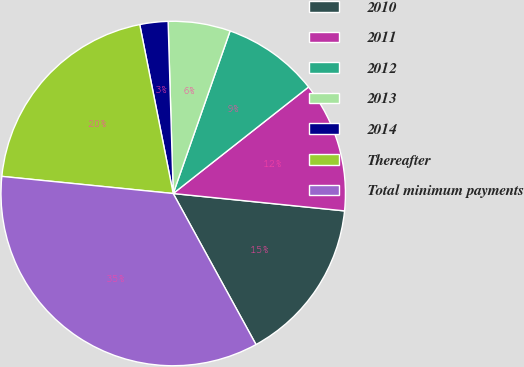Convert chart to OTSL. <chart><loc_0><loc_0><loc_500><loc_500><pie_chart><fcel>2010<fcel>2011<fcel>2012<fcel>2013<fcel>2014<fcel>Thereafter<fcel>Total minimum payments<nl><fcel>15.41%<fcel>12.22%<fcel>9.03%<fcel>5.83%<fcel>2.64%<fcel>20.3%<fcel>34.57%<nl></chart> 